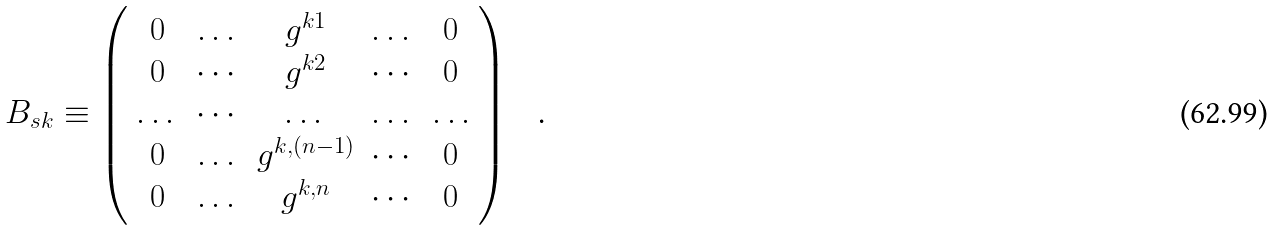Convert formula to latex. <formula><loc_0><loc_0><loc_500><loc_500>B _ { s k } \equiv \left ( \begin{array} { c c c c c } 0 & \dots & g ^ { k 1 } & \dots & 0 \\ 0 & \cdots & g ^ { k 2 } & \cdots & 0 \\ \dots & \cdots & \dots & \dots & \dots \\ 0 & \dots & g ^ { k , ( n - 1 ) } & \cdots & 0 \\ 0 & \dots & g ^ { k , n } & \cdots & 0 \end{array} \right ) \text { \ \ .}</formula> 